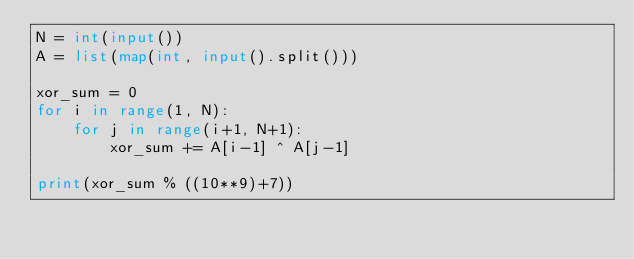<code> <loc_0><loc_0><loc_500><loc_500><_Python_>N = int(input())
A = list(map(int, input().split()))

xor_sum = 0
for i in range(1, N):
    for j in range(i+1, N+1):
        xor_sum += A[i-1] ^ A[j-1]

print(xor_sum % ((10**9)+7))</code> 